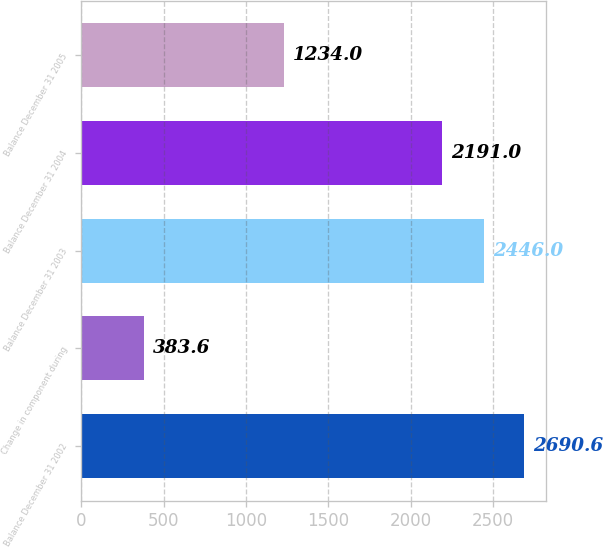<chart> <loc_0><loc_0><loc_500><loc_500><bar_chart><fcel>Balance December 31 2002<fcel>Change in component during<fcel>Balance December 31 2003<fcel>Balance December 31 2004<fcel>Balance December 31 2005<nl><fcel>2690.6<fcel>383.6<fcel>2446<fcel>2191<fcel>1234<nl></chart> 